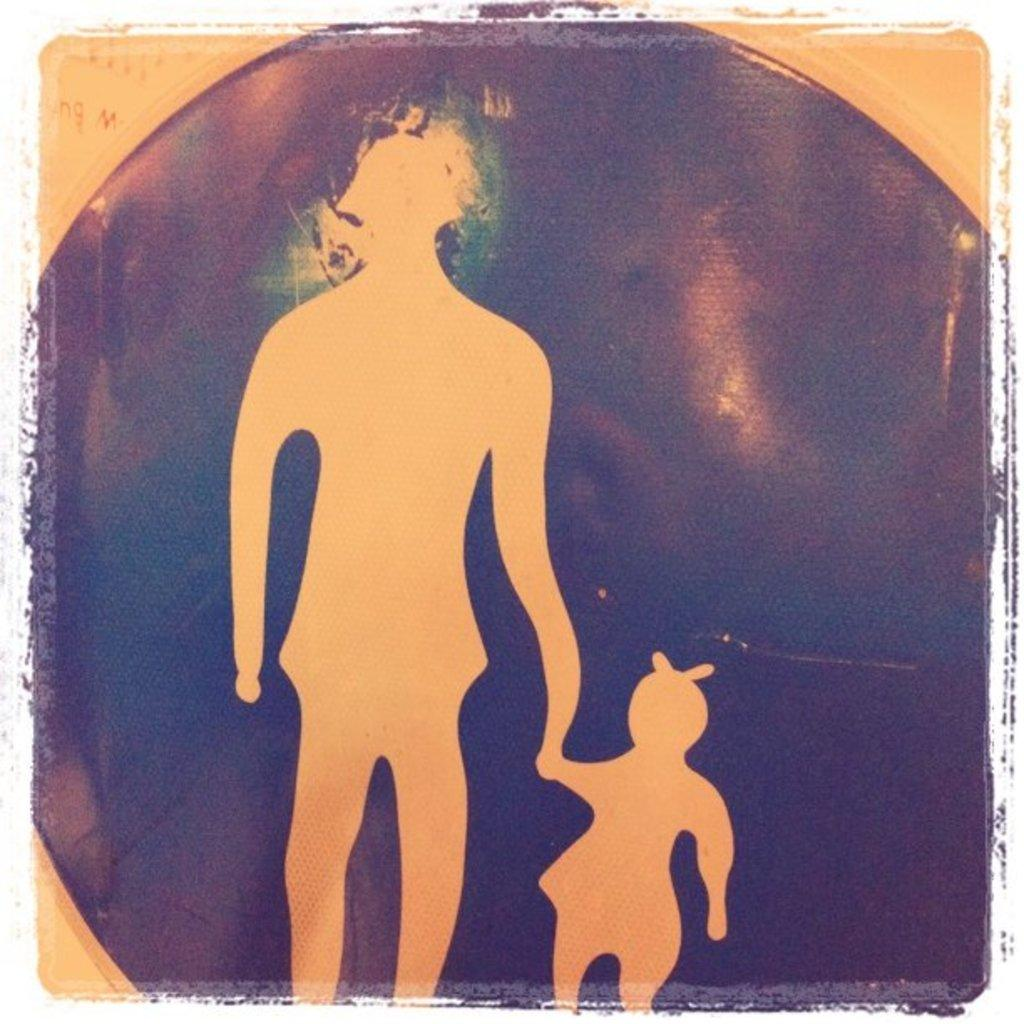What is present in the image? There is a poster in the image. What can be seen on the poster? The poster contains animated persons. What type of plastic object is being used by the girl in the image? There is no girl or plastic object present in the image; it only contains a poster with animated persons. 